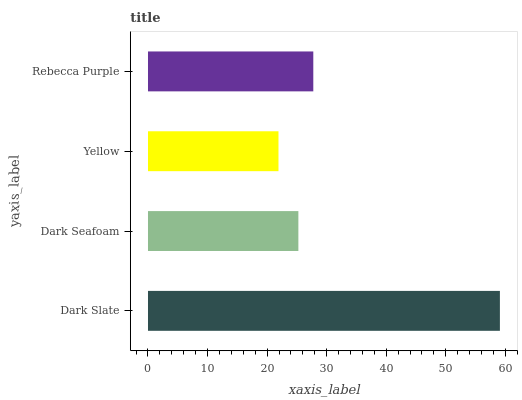Is Yellow the minimum?
Answer yes or no. Yes. Is Dark Slate the maximum?
Answer yes or no. Yes. Is Dark Seafoam the minimum?
Answer yes or no. No. Is Dark Seafoam the maximum?
Answer yes or no. No. Is Dark Slate greater than Dark Seafoam?
Answer yes or no. Yes. Is Dark Seafoam less than Dark Slate?
Answer yes or no. Yes. Is Dark Seafoam greater than Dark Slate?
Answer yes or no. No. Is Dark Slate less than Dark Seafoam?
Answer yes or no. No. Is Rebecca Purple the high median?
Answer yes or no. Yes. Is Dark Seafoam the low median?
Answer yes or no. Yes. Is Dark Seafoam the high median?
Answer yes or no. No. Is Yellow the low median?
Answer yes or no. No. 